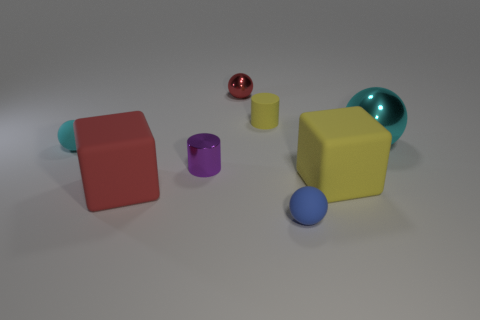Add 1 big cyan things. How many objects exist? 9 Subtract all small blue spheres. How many spheres are left? 3 Subtract all brown cylinders. How many cyan spheres are left? 2 Subtract all blocks. How many objects are left? 6 Subtract all red blocks. How many blocks are left? 1 Subtract 0 cyan cylinders. How many objects are left? 8 Subtract 3 spheres. How many spheres are left? 1 Subtract all brown spheres. Subtract all gray cylinders. How many spheres are left? 4 Subtract all tiny red objects. Subtract all yellow things. How many objects are left? 5 Add 3 blocks. How many blocks are left? 5 